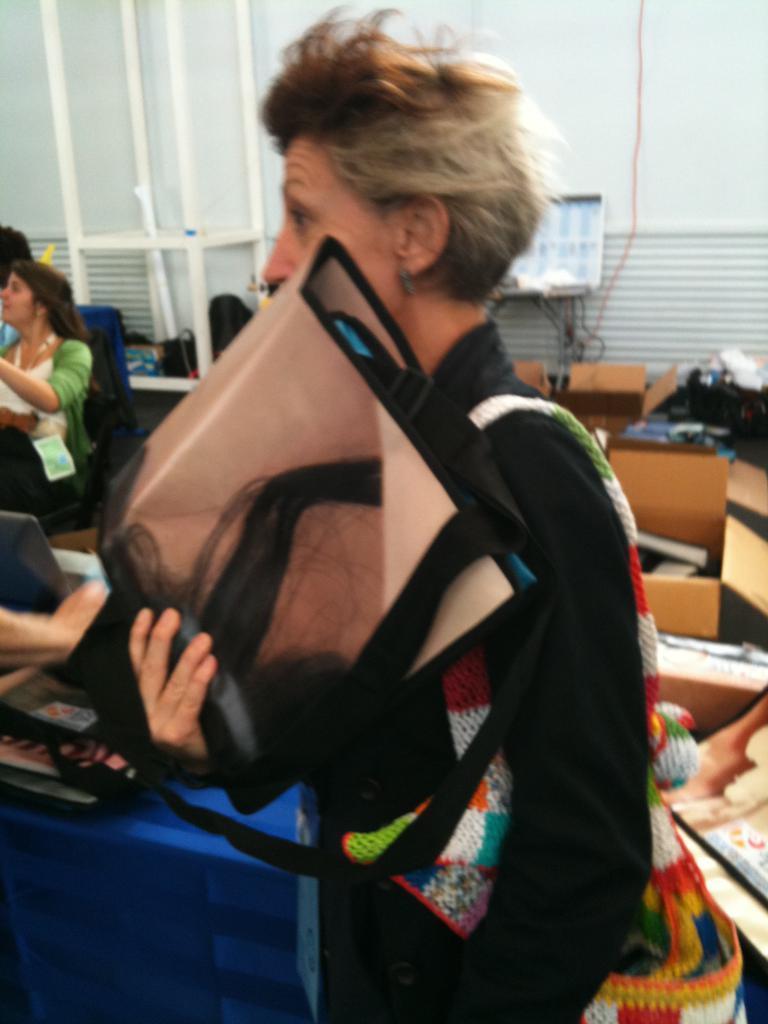How would you summarize this image in a sentence or two? In this image in the foreground we can see a person standing and holding a bag, and at the back we can see some people's, box. 